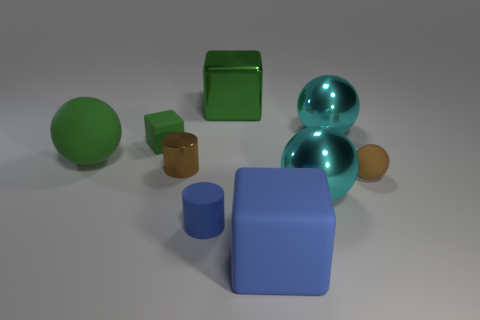Subtract all large green balls. How many balls are left? 3 Add 1 green matte objects. How many objects exist? 10 Subtract all blue cylinders. How many cylinders are left? 1 Subtract all cylinders. How many objects are left? 7 Subtract 2 cubes. How many cubes are left? 1 Add 4 small purple matte cubes. How many small purple matte cubes exist? 4 Subtract 1 blue cubes. How many objects are left? 8 Subtract all yellow cubes. Subtract all cyan cylinders. How many cubes are left? 3 Subtract all red blocks. How many brown balls are left? 1 Subtract all large blue matte blocks. Subtract all tiny brown balls. How many objects are left? 7 